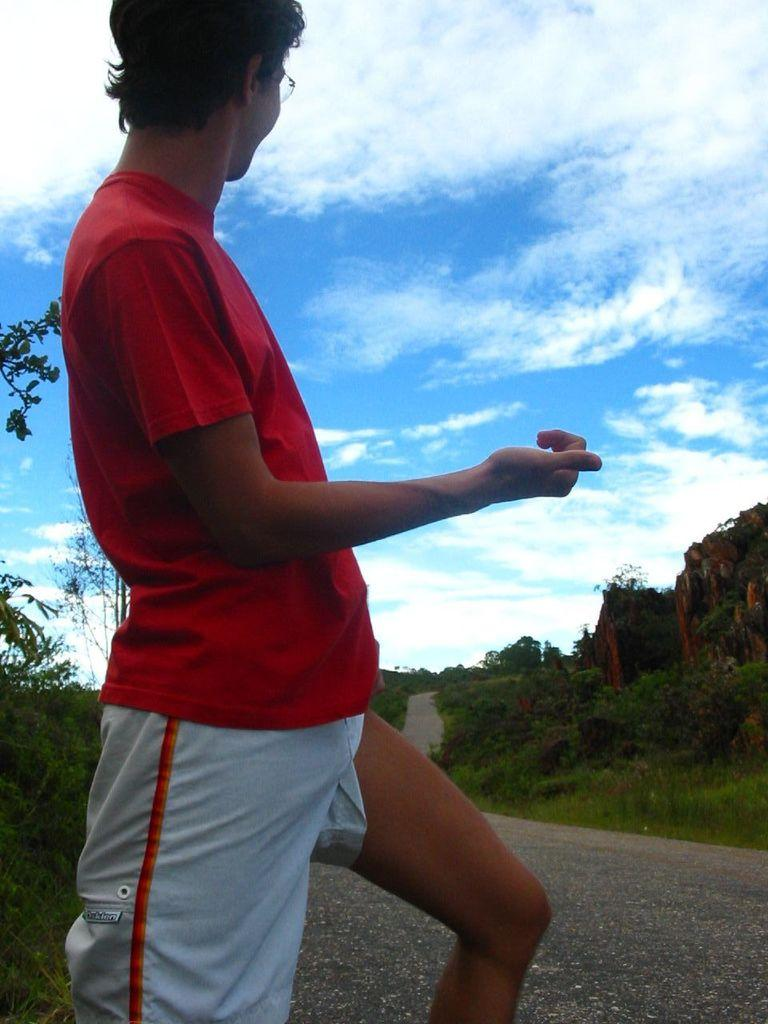What is the person in the image doing? The person is standing on the road in the image. What type of vegetation can be seen in the image? There is grass, plants, and trees visible in the image. What is visible in the background of the image? The sky is visible in the background of the image. What can be observed in the sky? Clouds are present in the sky. What type of pest can be seen crawling on the person's shoulder in the image? There is no pest visible on the person's shoulder in the image. 